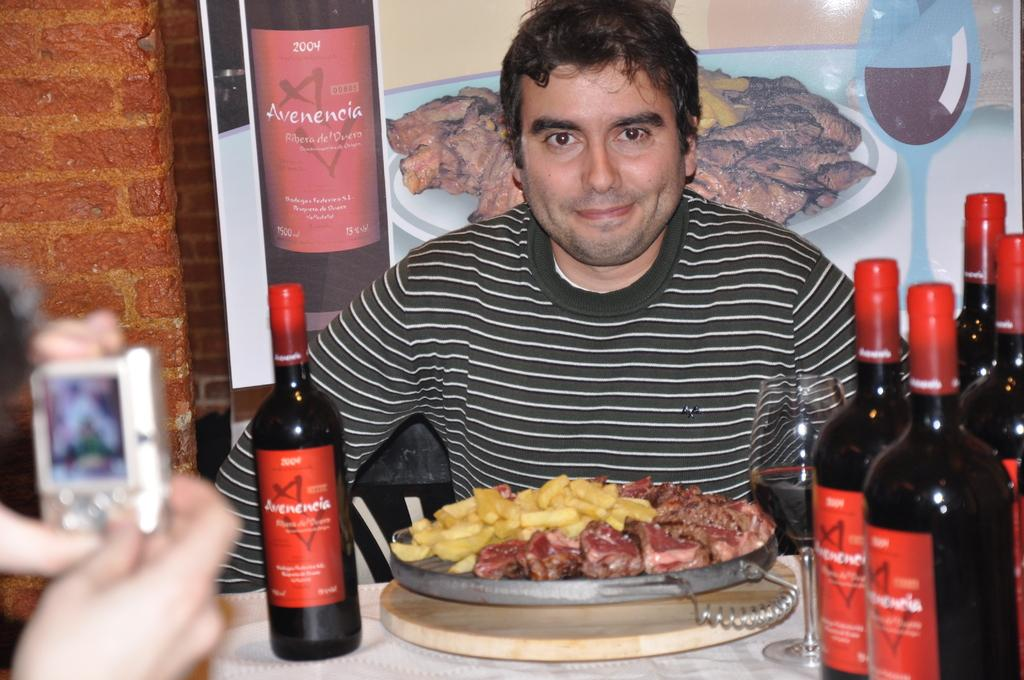<image>
Provide a brief description of the given image. Bottles of alcohol read Avenencia on their red labels. 